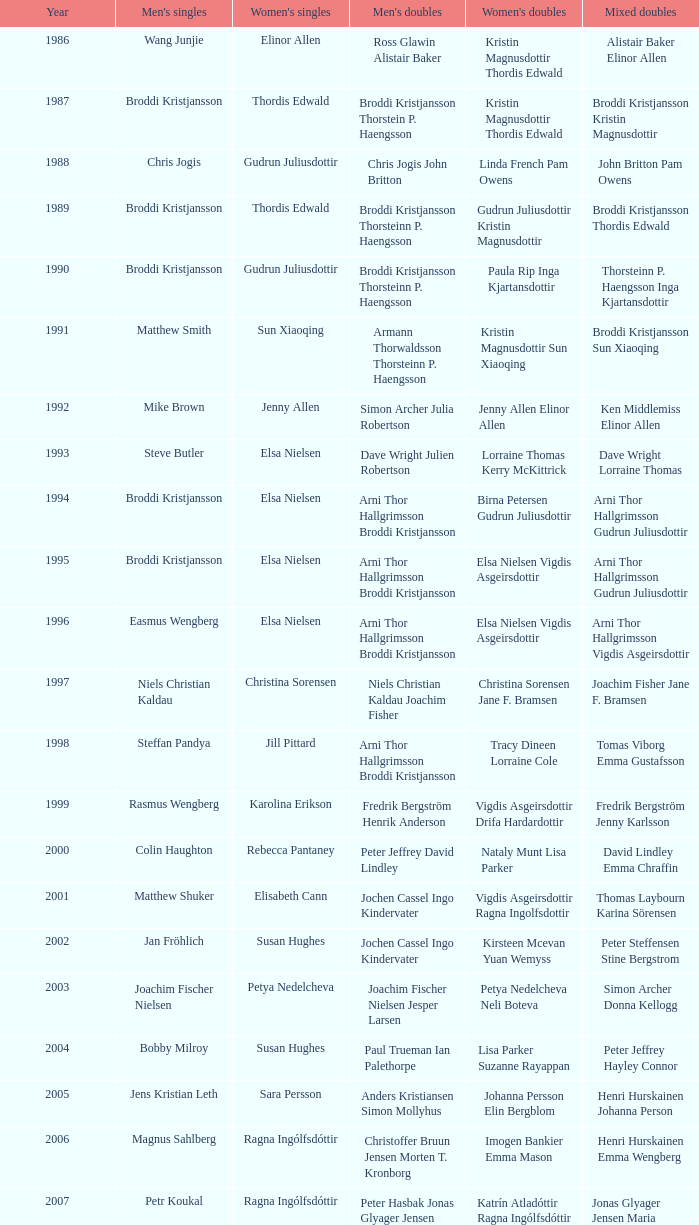In what mixed doubles did Niels Christian Kaldau play in men's singles? Joachim Fisher Jane F. Bramsen. 